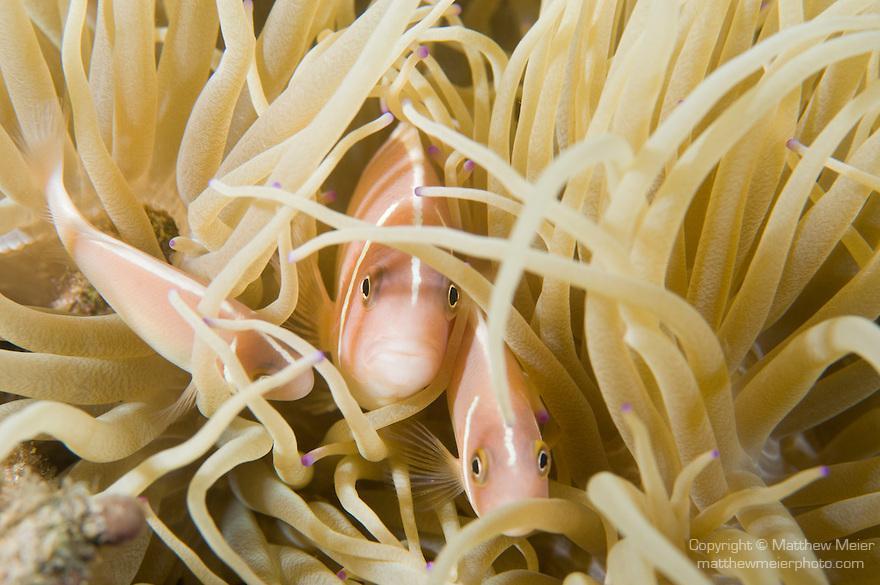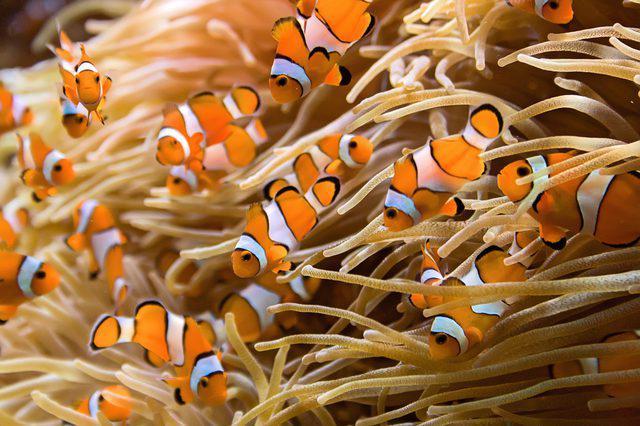The first image is the image on the left, the second image is the image on the right. Examine the images to the left and right. Is the description "Each image features no more than two orange fish in the foreground, and the fish in the left and right images are posed among anemone tendrils of the same color." accurate? Answer yes or no. No. The first image is the image on the left, the second image is the image on the right. Examine the images to the left and right. Is the description "In at least one image there is a single white clownfish with white, black and orange colors swimming through  the arms of corral." accurate? Answer yes or no. No. 